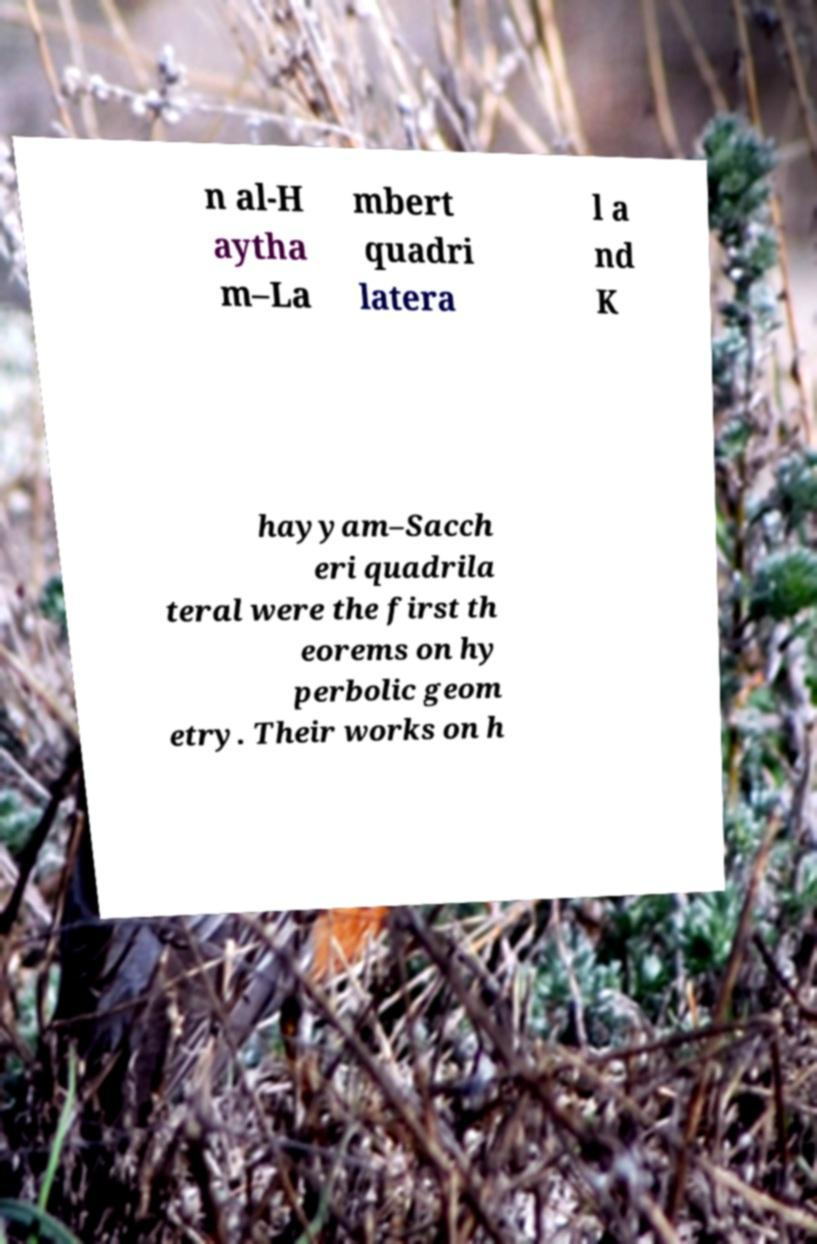Can you read and provide the text displayed in the image?This photo seems to have some interesting text. Can you extract and type it out for me? n al-H aytha m–La mbert quadri latera l a nd K hayyam–Sacch eri quadrila teral were the first th eorems on hy perbolic geom etry. Their works on h 